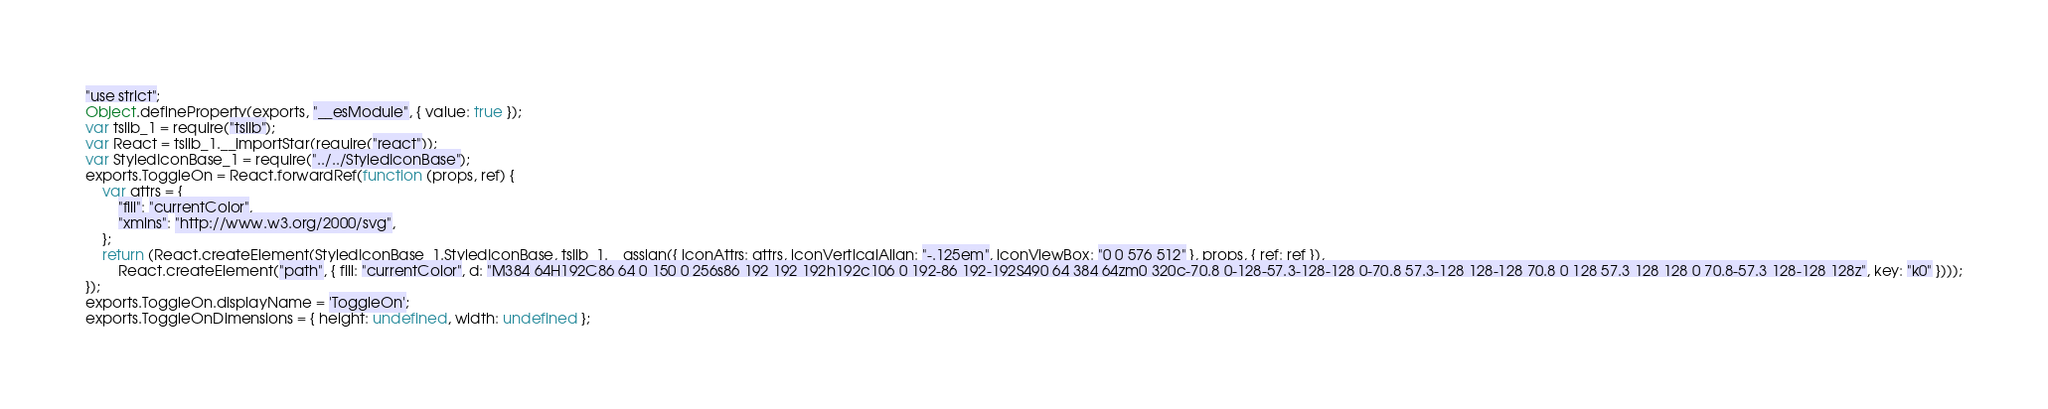Convert code to text. <code><loc_0><loc_0><loc_500><loc_500><_JavaScript_>"use strict";
Object.defineProperty(exports, "__esModule", { value: true });
var tslib_1 = require("tslib");
var React = tslib_1.__importStar(require("react"));
var StyledIconBase_1 = require("../../StyledIconBase");
exports.ToggleOn = React.forwardRef(function (props, ref) {
    var attrs = {
        "fill": "currentColor",
        "xmlns": "http://www.w3.org/2000/svg",
    };
    return (React.createElement(StyledIconBase_1.StyledIconBase, tslib_1.__assign({ iconAttrs: attrs, iconVerticalAlign: "-.125em", iconViewBox: "0 0 576 512" }, props, { ref: ref }),
        React.createElement("path", { fill: "currentColor", d: "M384 64H192C86 64 0 150 0 256s86 192 192 192h192c106 0 192-86 192-192S490 64 384 64zm0 320c-70.8 0-128-57.3-128-128 0-70.8 57.3-128 128-128 70.8 0 128 57.3 128 128 0 70.8-57.3 128-128 128z", key: "k0" })));
});
exports.ToggleOn.displayName = 'ToggleOn';
exports.ToggleOnDimensions = { height: undefined, width: undefined };
</code> 